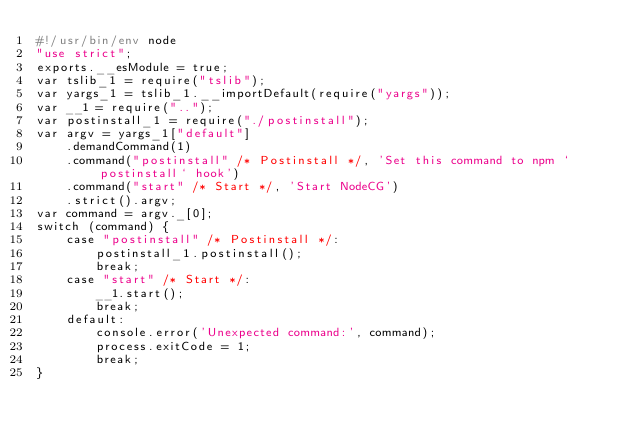Convert code to text. <code><loc_0><loc_0><loc_500><loc_500><_JavaScript_>#!/usr/bin/env node
"use strict";
exports.__esModule = true;
var tslib_1 = require("tslib");
var yargs_1 = tslib_1.__importDefault(require("yargs"));
var __1 = require("..");
var postinstall_1 = require("./postinstall");
var argv = yargs_1["default"]
    .demandCommand(1)
    .command("postinstall" /* Postinstall */, 'Set this command to npm `postinstall` hook')
    .command("start" /* Start */, 'Start NodeCG')
    .strict().argv;
var command = argv._[0];
switch (command) {
    case "postinstall" /* Postinstall */:
        postinstall_1.postinstall();
        break;
    case "start" /* Start */:
        __1.start();
        break;
    default:
        console.error('Unexpected command:', command);
        process.exitCode = 1;
        break;
}
</code> 